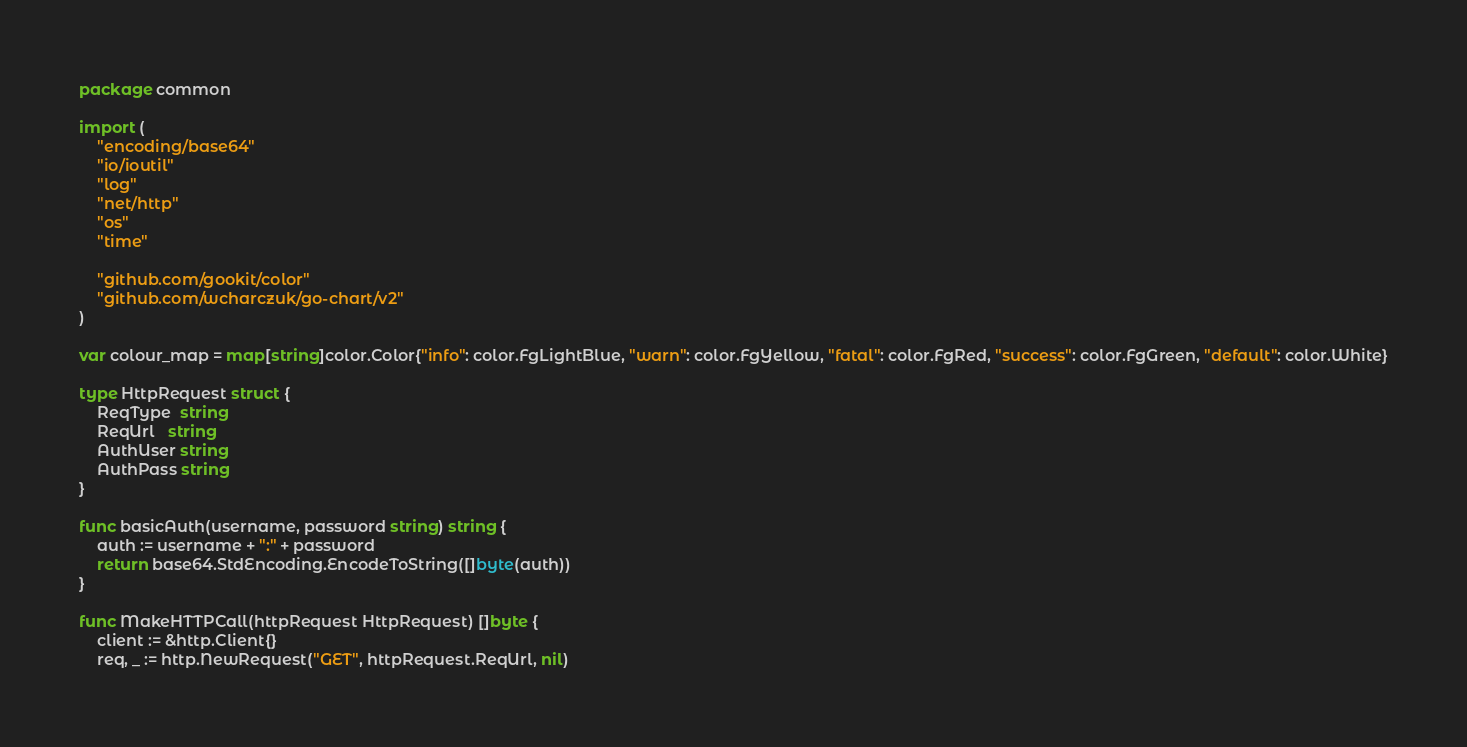Convert code to text. <code><loc_0><loc_0><loc_500><loc_500><_Go_>package common

import (
	"encoding/base64"
	"io/ioutil"
	"log"
	"net/http"
	"os"
	"time"

	"github.com/gookit/color"
	"github.com/wcharczuk/go-chart/v2"
)

var colour_map = map[string]color.Color{"info": color.FgLightBlue, "warn": color.FgYellow, "fatal": color.FgRed, "success": color.FgGreen, "default": color.White}

type HttpRequest struct {
	ReqType  string
	ReqUrl   string
	AuthUser string
	AuthPass string
}

func basicAuth(username, password string) string {
	auth := username + ":" + password
	return base64.StdEncoding.EncodeToString([]byte(auth))
}

func MakeHTTPCall(httpRequest HttpRequest) []byte {
	client := &http.Client{}
	req, _ := http.NewRequest("GET", httpRequest.ReqUrl, nil)</code> 